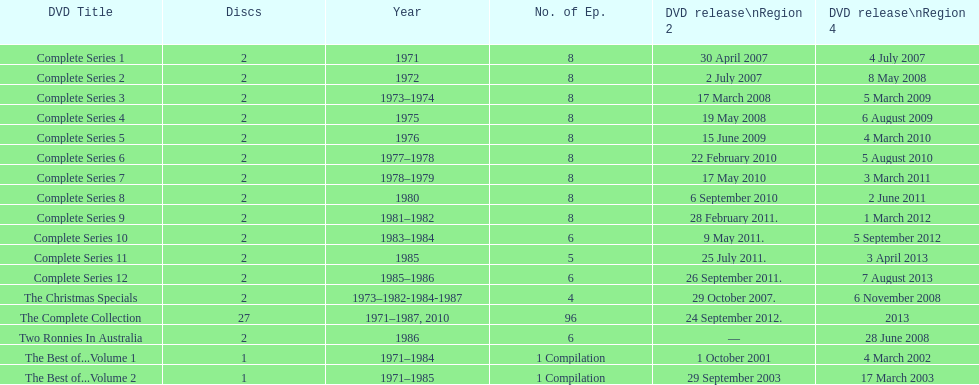Total number of episodes released in region 2 in 2007 20. 